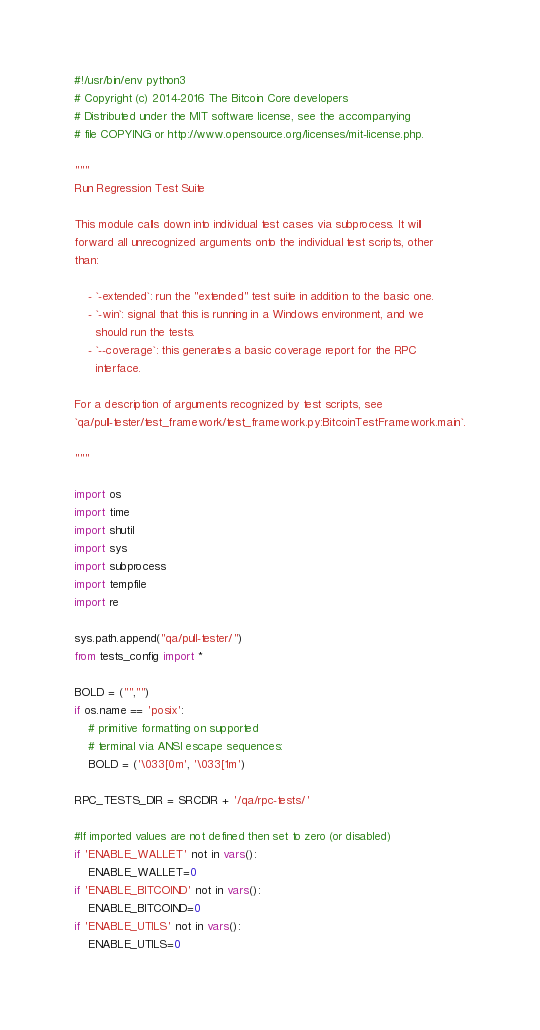<code> <loc_0><loc_0><loc_500><loc_500><_Python_>#!/usr/bin/env python3
# Copyright (c) 2014-2016 The Bitcoin Core developers
# Distributed under the MIT software license, see the accompanying
# file COPYING or http://www.opensource.org/licenses/mit-license.php.

"""
Run Regression Test Suite

This module calls down into individual test cases via subprocess. It will
forward all unrecognized arguments onto the individual test scripts, other
than:

    - `-extended`: run the "extended" test suite in addition to the basic one.
    - `-win`: signal that this is running in a Windows environment, and we
      should run the tests.
    - `--coverage`: this generates a basic coverage report for the RPC
      interface.

For a description of arguments recognized by test scripts, see
`qa/pull-tester/test_framework/test_framework.py:BitcoinTestFramework.main`.

"""

import os
import time
import shutil
import sys
import subprocess
import tempfile
import re

sys.path.append("qa/pull-tester/")
from tests_config import *

BOLD = ("","")
if os.name == 'posix':
    # primitive formatting on supported
    # terminal via ANSI escape sequences:
    BOLD = ('\033[0m', '\033[1m')

RPC_TESTS_DIR = SRCDIR + '/qa/rpc-tests/'

#If imported values are not defined then set to zero (or disabled)
if 'ENABLE_WALLET' not in vars():
    ENABLE_WALLET=0
if 'ENABLE_BITCOIND' not in vars():
    ENABLE_BITCOIND=0
if 'ENABLE_UTILS' not in vars():
    ENABLE_UTILS=0</code> 